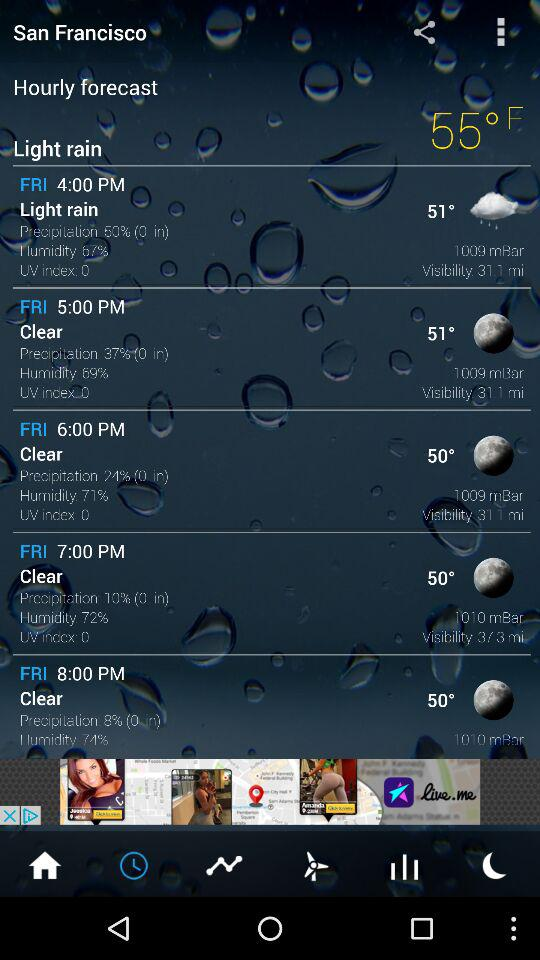What is the humidity percentage shown on the screen at 7:00 pm? The humidity percentage shown on the screen at 7:00 pm is 72. 